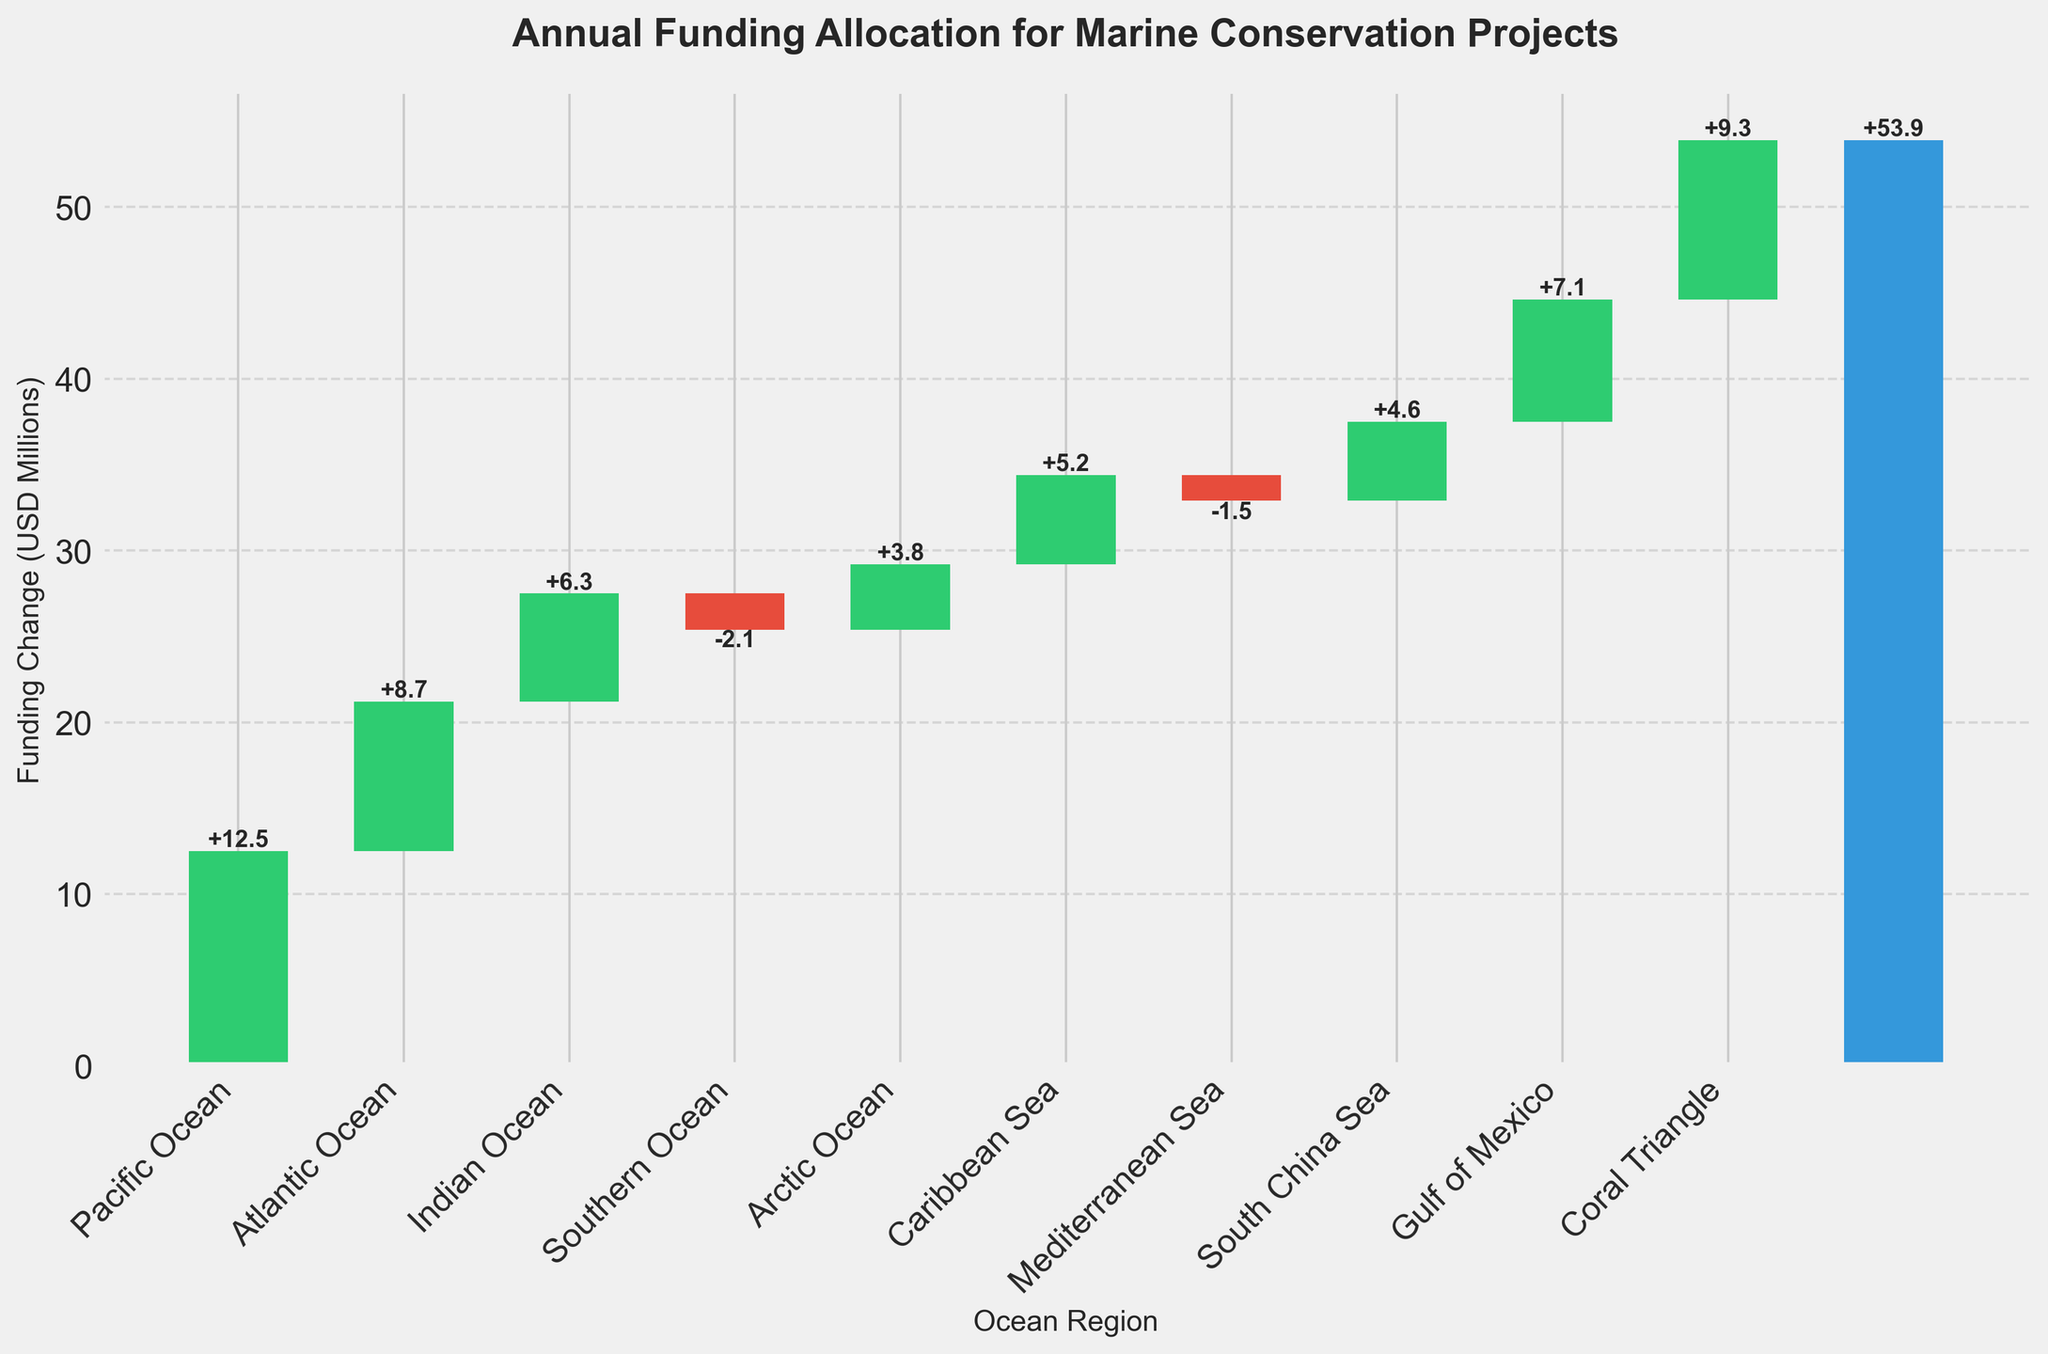What's the title of the chart? The title of the chart is written at the top and reads "Annual Funding Allocation for Marine Conservation Projects".
Answer: Annual Funding Allocation for Marine Conservation Projects What is the total change in funding? The total change is the final value marked by the bar at the end, which is also indicated by the label.
Answer: 53.9 USD Millions How much funding change does the Coral Triangle region receive? The funding change for the Coral Triangle region is labeled directly on its bar, indicated as 9.3 USD Millions.
Answer: 9.3 USD Millions Which two regions experienced a decrease in funding? The regions with negative funding change are indicated by the red bars and labeled directly as Southern Ocean (-2.1) and Mediterranean Sea (-1.5).
Answer: Southern Ocean and Mediterranean Sea What is the sum of the funding changes for the Pacific Ocean and Atlantic Ocean regions? The funding change for Pacific Ocean is 12.5 and for Atlantic Ocean is 8.7. Summing these gives 12.5 + 8.7 = 21.2 USD Millions.
Answer: 21.2 USD Millions Which region received the second highest increase in funding? The bar heights and labels indicate that after Pacific Ocean (12.5 USD Millions), Coral Triangle (9.3 USD Millions) has the second highest increase in funding.
Answer: Coral Triangle How much more funding did the Gulf of Mexico receive compared to the Caribbean Sea? The funding change for the Gulf of Mexico is 7.1 USD Millions and for the Caribbean Sea is 5.2 USD Millions. The difference is 7.1 - 5.2 = 1.9 USD Millions.
Answer: 1.9 USD Millions What is the average funding change across all ocean regions (excluding total change)? Sum all increases: 12.5 + 8.7 + 6.3 + 3.8 + 5.2 + 4.6 + 7.1 + 9.3 = 57.5, and decreases: -2.1 - 1.5 = -3.6. The total funding change = 57.5 + (-3.6) = 53.9. The number of regions = 9. Average = 53.9/9 ≈ 5.99 USD Millions.
Answer: 5.99 USD Millions Which regions have funding changes greater than 5 million USD? By observing the bar heights and labels, the regions are Pacific Ocean (12.5), Atlantic Ocean (8.7), Coral Triangle (9.3), Gulf of Mexico (7.1), and Caribbean Sea (5.2).
Answer: Pacific Ocean, Atlantic Ocean, Coral Triangle, Gulf of Mexico, Caribbean Sea How did the Indian Ocean's funding change compare to the Arctic Ocean's? The funding change for Indian Ocean is 6.3 USD Millions and for Arctic Ocean is 3.8 USD Millions. Indian Ocean received 6.3 - 3.8 = 2.5 USD Millions more than Arctic Ocean.
Answer: 2.5 USD Millions more for Indian Ocean 